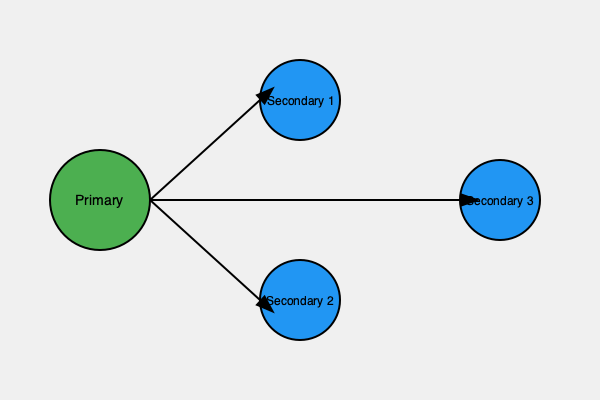In the given network diagram representing a distributed database system for our e-commerce platform, which consistency model is most likely being implemented, and what potential challenge might arise during high-traffic periods? To answer this question, let's analyze the diagram and consider the implications for our e-commerce platform:

1. Structure: The diagram shows a primary database with three secondary databases, indicating a primary-secondary replication model.

2. Arrows: Unidirectional arrows from the primary to secondaries suggest asynchronous replication.

3. Consistency model:
   - This setup typically implements eventual consistency.
   - In eventual consistency, updates are propagated asynchronously from the primary to secondaries.
   - It allows for high availability and partition tolerance but may sacrifice immediate consistency.

4. E-commerce context:
   - For an e-commerce platform, this model can handle high read loads by distributing reads across secondaries.
   - Writes are directed to the primary database to maintain order and avoid conflicts.

5. Potential challenge during high-traffic periods:
   - Replication lag: As write operations increase during high traffic, there may be a delay in propagating updates to secondaries.
   - This can lead to temporary inconsistencies where secondaries don't reflect the most recent data from the primary.

6. Impact on e-commerce operations:
   - Customers might see outdated inventory information or order status.
   - This could result in overselling or displaying incorrect product availability.

Therefore, the most likely consistency model is eventual consistency, and the potential challenge during high-traffic periods is replication lag leading to temporary data inconsistencies across the system.
Answer: Eventual consistency; replication lag 